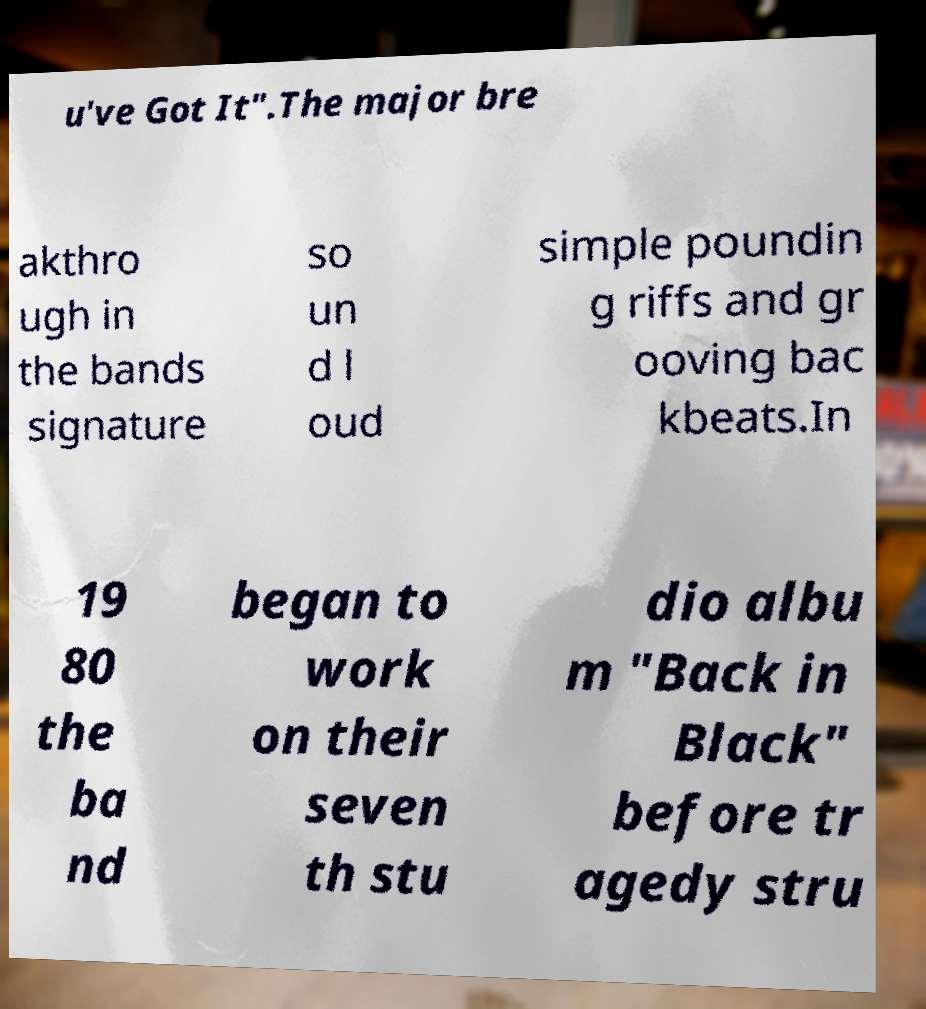Please read and relay the text visible in this image. What does it say? u've Got It".The major bre akthro ugh in the bands signature so un d l oud simple poundin g riffs and gr ooving bac kbeats.In 19 80 the ba nd began to work on their seven th stu dio albu m "Back in Black" before tr agedy stru 